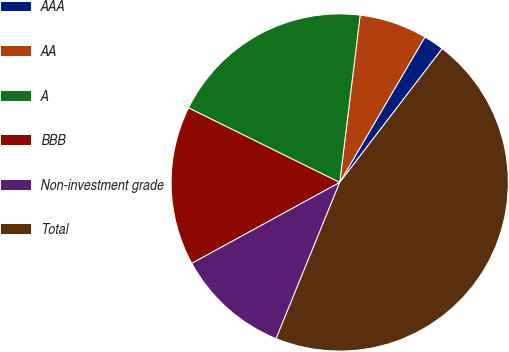Convert chart. <chart><loc_0><loc_0><loc_500><loc_500><pie_chart><fcel>AAA<fcel>AA<fcel>A<fcel>BBB<fcel>Non-investment grade<fcel>Total<nl><fcel>1.97%<fcel>6.5%<fcel>19.64%<fcel>15.26%<fcel>10.88%<fcel>45.76%<nl></chart> 